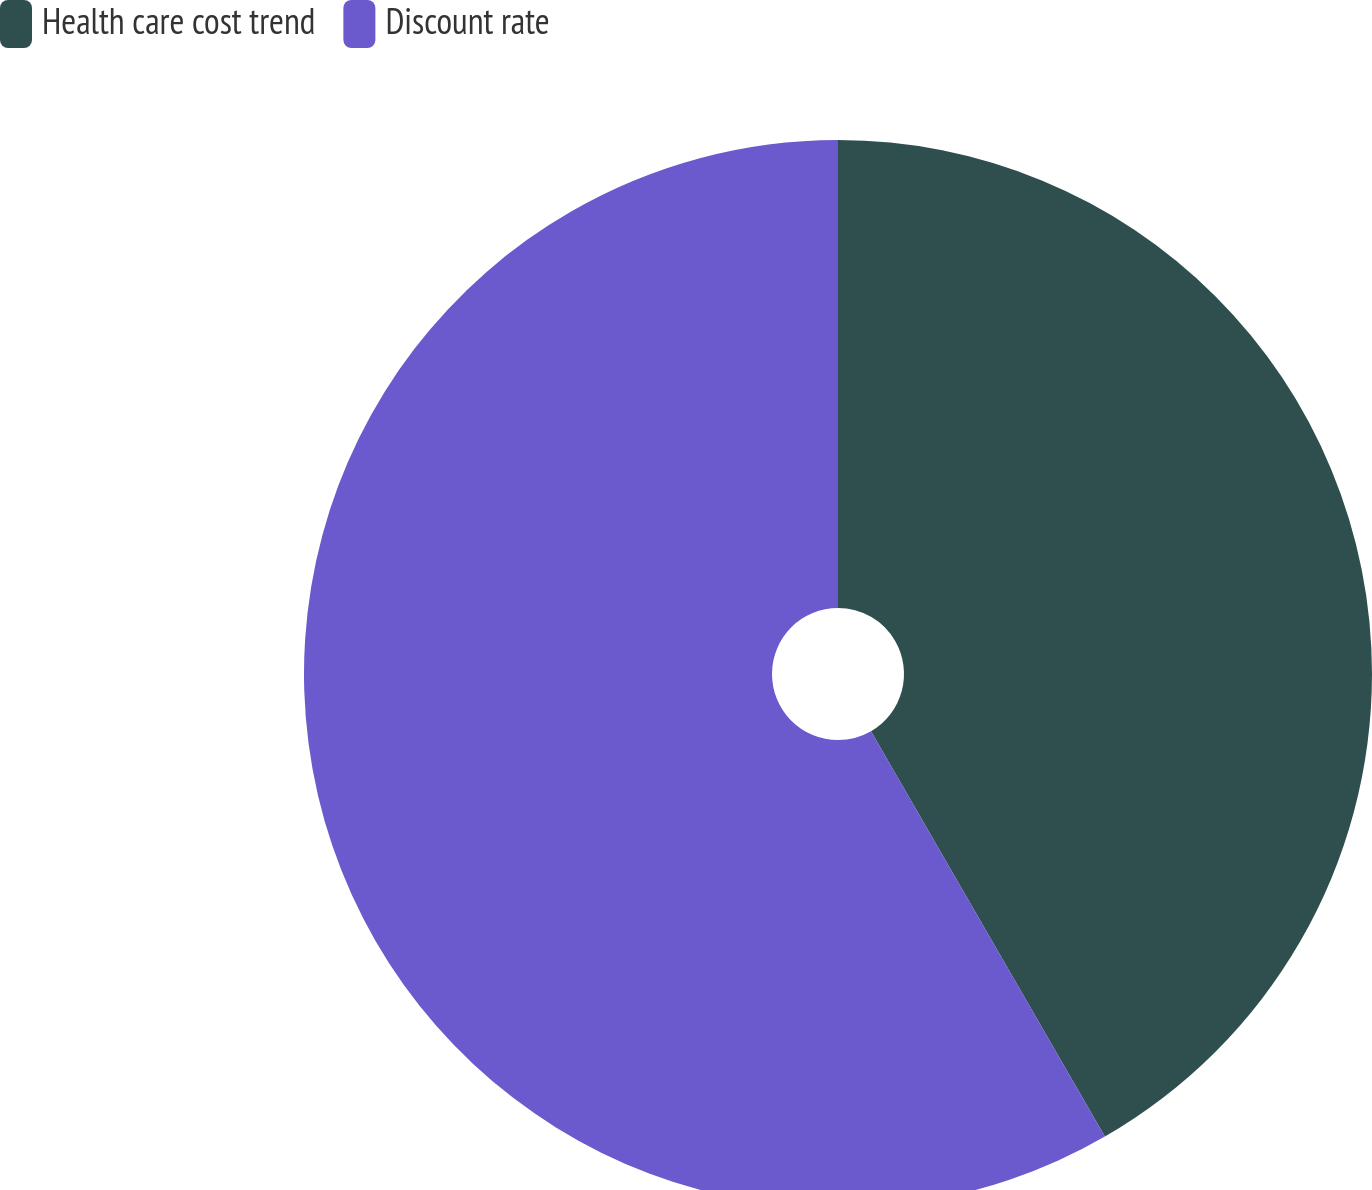Convert chart to OTSL. <chart><loc_0><loc_0><loc_500><loc_500><pie_chart><fcel>Health care cost trend<fcel>Discount rate<nl><fcel>41.67%<fcel>58.33%<nl></chart> 